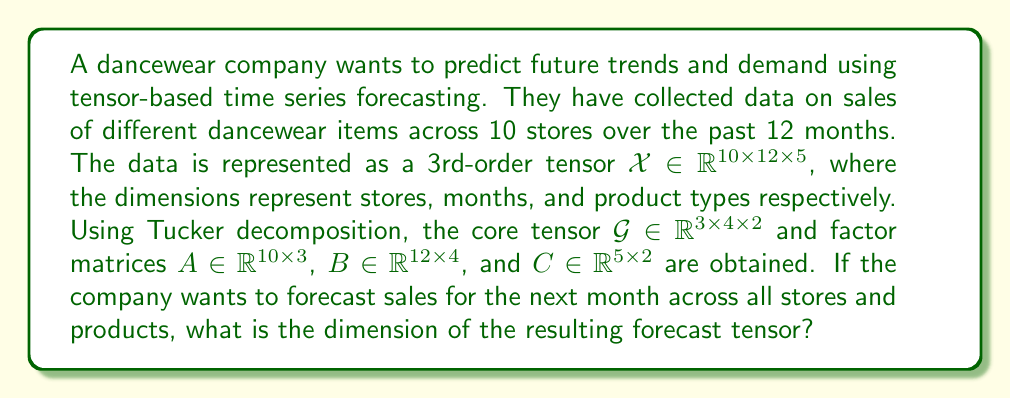Help me with this question. Let's approach this step-by-step:

1) The original data tensor $\mathcal{X}$ has dimensions $10 \times 12 \times 5$, representing stores, months, and product types.

2) The Tucker decomposition of $\mathcal{X}$ is given by:

   $$\mathcal{X} \approx \mathcal{G} \times_1 A \times_2 B \times_3 C$$

   where $\mathcal{G}$ is the core tensor and $A$, $B$, $C$ are factor matrices.

3) To forecast for the next month, we need to extend the time dimension. This is typically done by augmenting the factor matrix $B$ with a new row vector $b_{new} \in \mathbb{R}^{1 \times 4}$.

4) The new time factor matrix $B_{new}$ will have dimensions $(12+1) \times 4 = 13 \times 4$.

5) The forecast tensor $\mathcal{X}_{forecast}$ is then computed as:

   $$\mathcal{X}_{forecast} = \mathcal{G} \times_1 A \times_2 B_{new} \times_3 C$$

6) The resulting dimensions of $\mathcal{X}_{forecast}$ will be:
   - 1st dimension (stores): 10 (same as $A$)
   - 2nd dimension (months): 13 (new dimension of $B_{new}$)
   - 3rd dimension (product types): 5 (same as $C$)

Therefore, the forecast tensor $\mathcal{X}_{forecast}$ will have dimensions $10 \times 13 \times 5$.
Answer: $10 \times 13 \times 5$ 